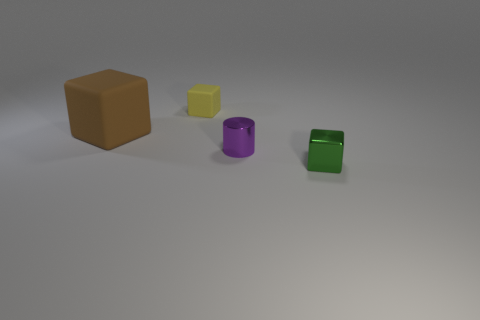There is a matte thing that is to the left of the yellow matte cube; is its shape the same as the tiny green thing?
Make the answer very short. Yes. Is the number of large brown objects on the left side of the big brown matte block greater than the number of tiny green objects?
Provide a short and direct response. No. There is a block that is in front of the small matte object and left of the tiny cylinder; what is its material?
Make the answer very short. Rubber. Is there anything else that has the same shape as the tiny purple shiny thing?
Provide a succinct answer. No. What number of cubes are to the left of the yellow block and in front of the tiny purple cylinder?
Keep it short and to the point. 0. What is the material of the large brown block?
Your answer should be compact. Rubber. Are there an equal number of big brown cubes that are right of the small yellow object and tiny red balls?
Keep it short and to the point. Yes. How many tiny green things are the same shape as the big object?
Provide a short and direct response. 1. Is the big brown thing the same shape as the small yellow matte object?
Make the answer very short. Yes. What number of things are rubber things that are left of the tiny shiny cube or small objects?
Offer a terse response. 4. 